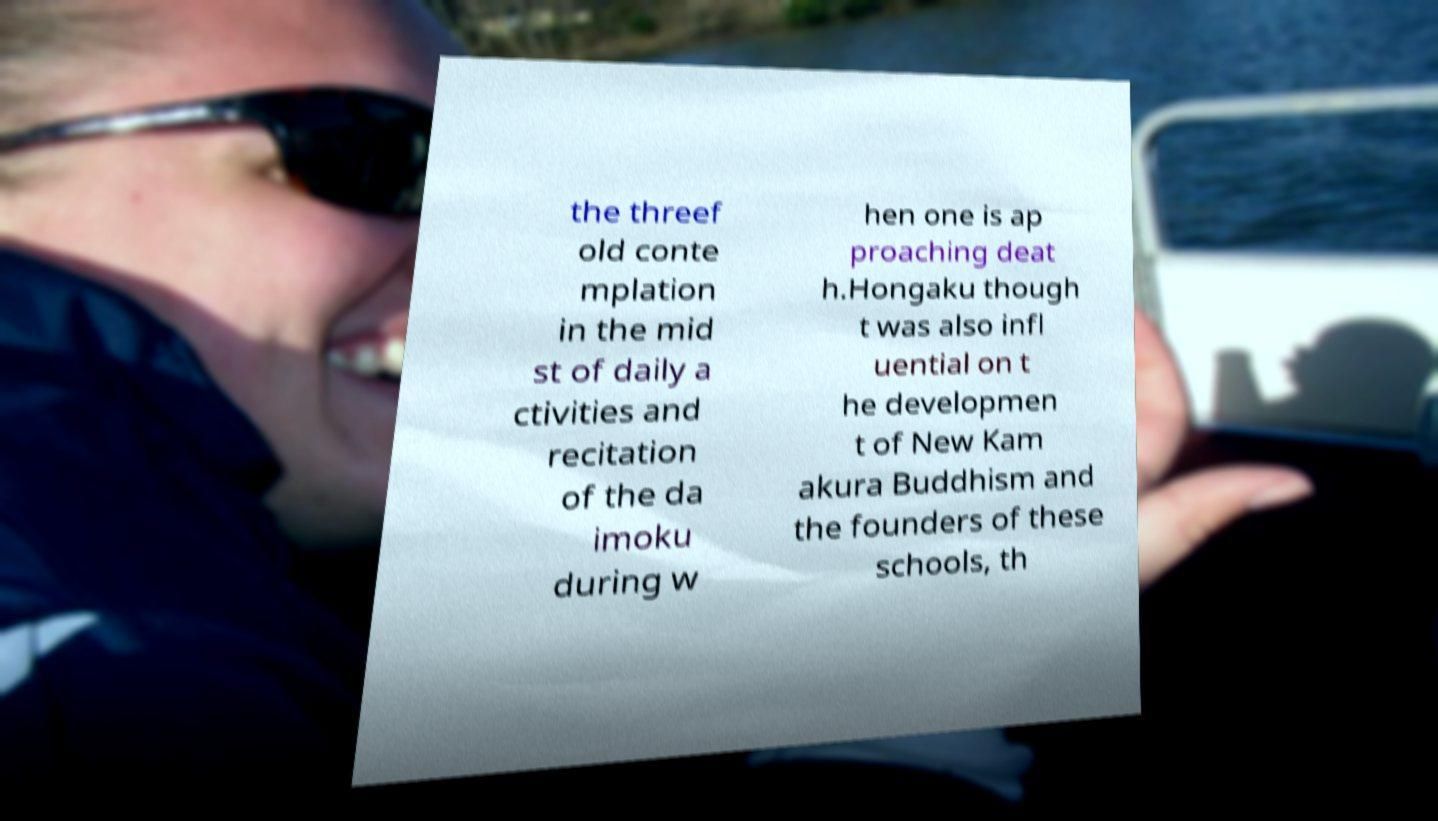Please identify and transcribe the text found in this image. the threef old conte mplation in the mid st of daily a ctivities and recitation of the da imoku during w hen one is ap proaching deat h.Hongaku though t was also infl uential on t he developmen t of New Kam akura Buddhism and the founders of these schools, th 